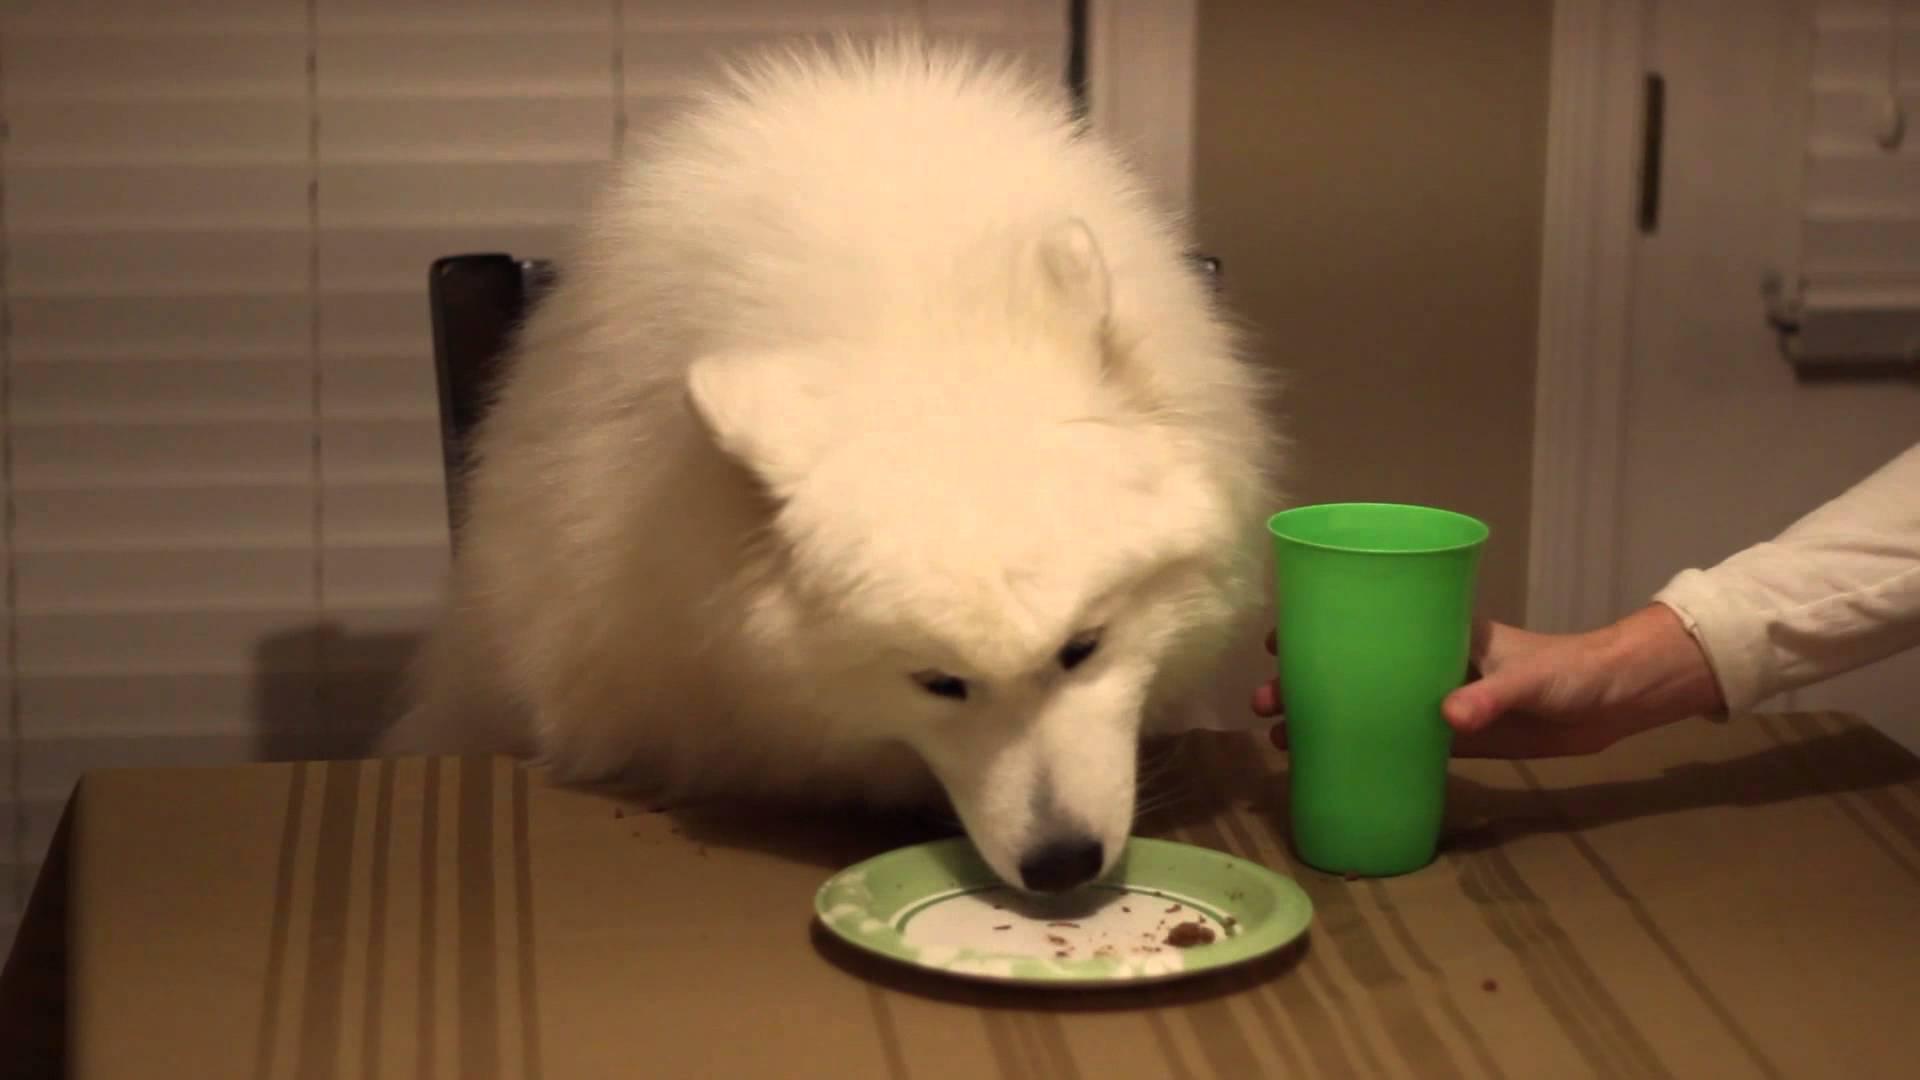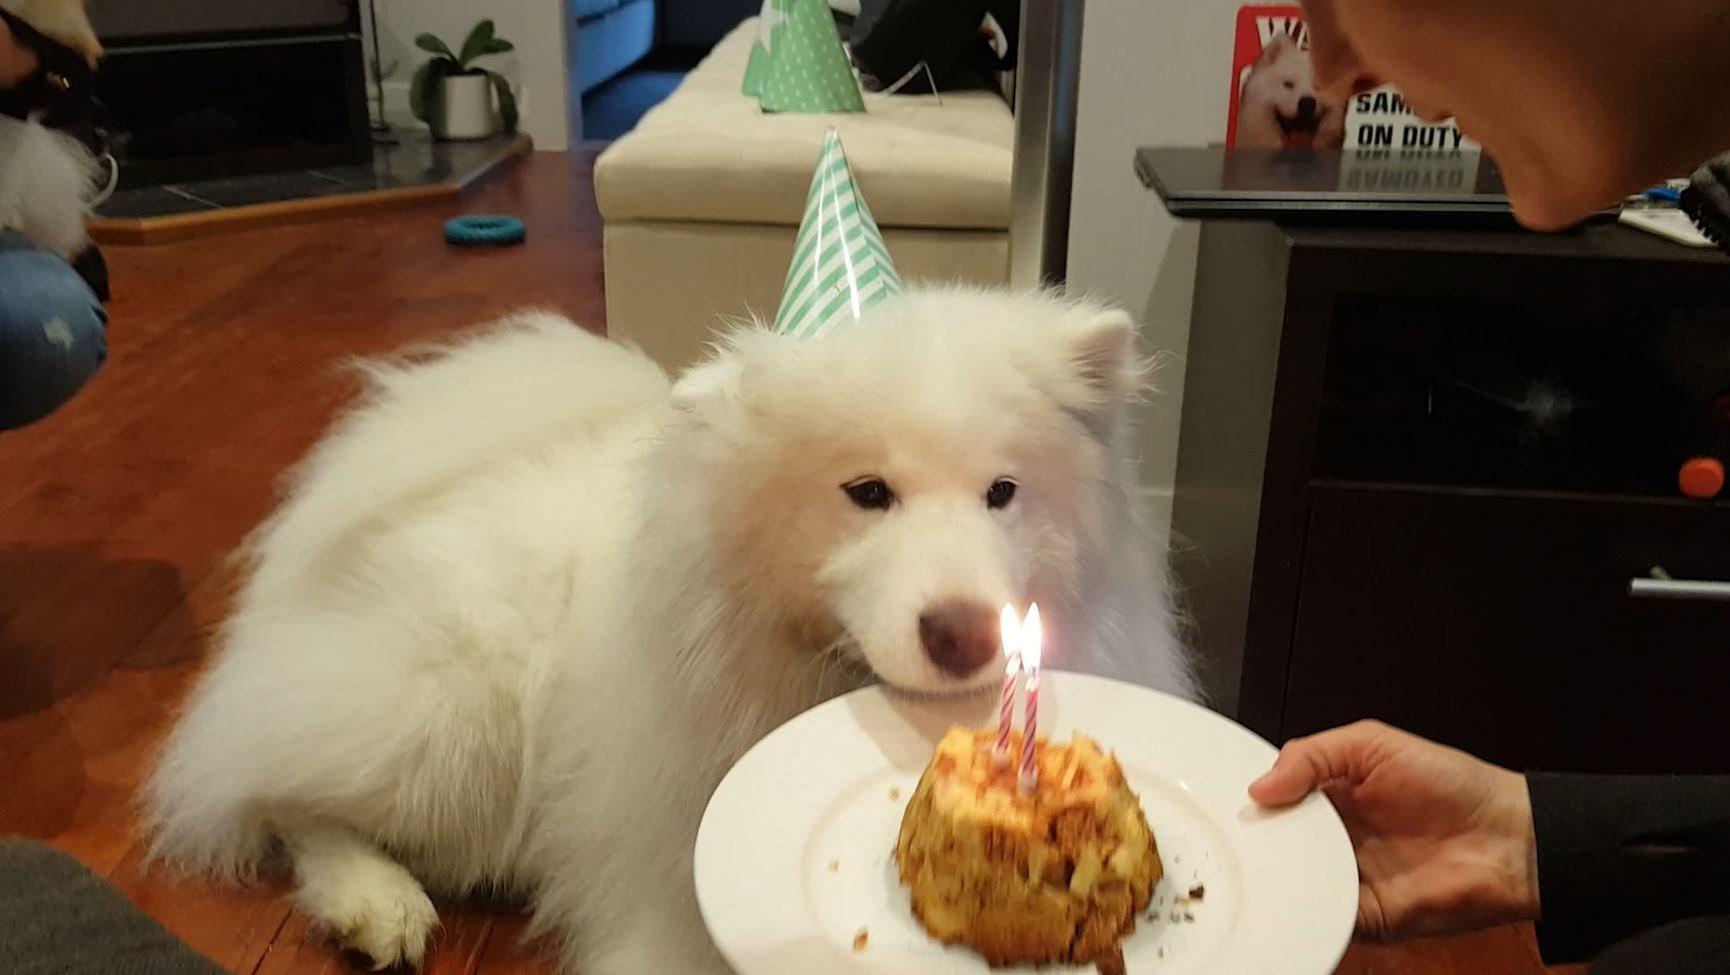The first image is the image on the left, the second image is the image on the right. For the images displayed, is the sentence "The leftmost image has a dog sitting in a chair, at a table with a plate or bowl and a cup in front of them." factually correct? Answer yes or no. Yes. The first image is the image on the left, the second image is the image on the right. Evaluate the accuracy of this statement regarding the images: "A puppy on a checkered blanket next to a picnic basket". Is it true? Answer yes or no. No. 